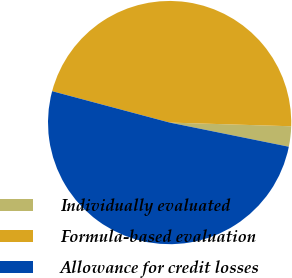<chart> <loc_0><loc_0><loc_500><loc_500><pie_chart><fcel>Individually evaluated<fcel>Formula-based evaluation<fcel>Allowance for credit losses<nl><fcel>2.7%<fcel>46.33%<fcel>50.97%<nl></chart> 